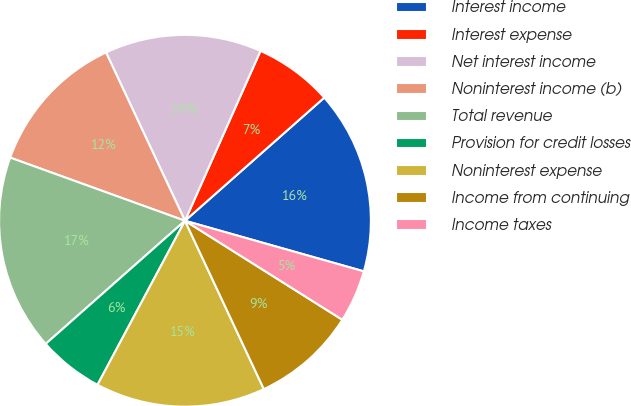<chart> <loc_0><loc_0><loc_500><loc_500><pie_chart><fcel>Interest income<fcel>Interest expense<fcel>Net interest income<fcel>Noninterest income (b)<fcel>Total revenue<fcel>Provision for credit losses<fcel>Noninterest expense<fcel>Income from continuing<fcel>Income taxes<nl><fcel>15.91%<fcel>6.82%<fcel>13.64%<fcel>12.5%<fcel>17.04%<fcel>5.68%<fcel>14.77%<fcel>9.09%<fcel>4.55%<nl></chart> 